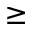<formula> <loc_0><loc_0><loc_500><loc_500>\geq</formula> 